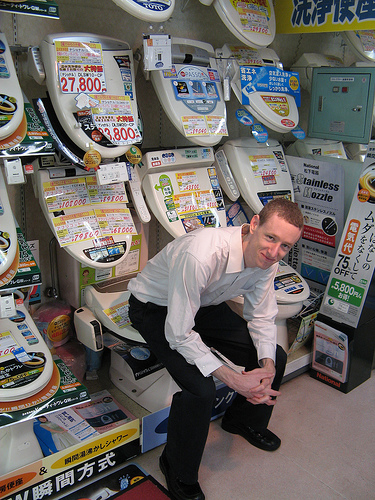What is the boy on? The boy is showcasing a toilet model by sitting on it, demonstrating its use in a humorous manner. 